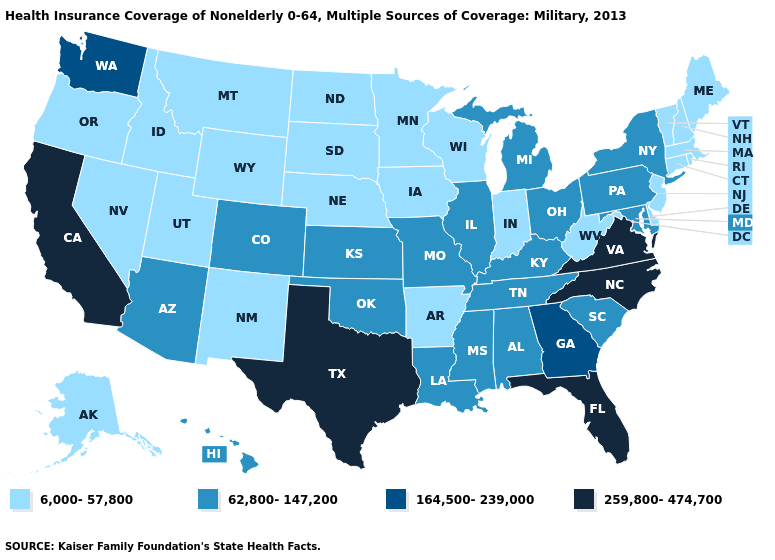Does Utah have the lowest value in the West?
Concise answer only. Yes. Name the states that have a value in the range 6,000-57,800?
Answer briefly. Alaska, Arkansas, Connecticut, Delaware, Idaho, Indiana, Iowa, Maine, Massachusetts, Minnesota, Montana, Nebraska, Nevada, New Hampshire, New Jersey, New Mexico, North Dakota, Oregon, Rhode Island, South Dakota, Utah, Vermont, West Virginia, Wisconsin, Wyoming. Which states hav the highest value in the South?
Write a very short answer. Florida, North Carolina, Texas, Virginia. Does South Carolina have a lower value than North Carolina?
Short answer required. Yes. Name the states that have a value in the range 62,800-147,200?
Concise answer only. Alabama, Arizona, Colorado, Hawaii, Illinois, Kansas, Kentucky, Louisiana, Maryland, Michigan, Mississippi, Missouri, New York, Ohio, Oklahoma, Pennsylvania, South Carolina, Tennessee. What is the value of New Mexico?
Keep it brief. 6,000-57,800. Name the states that have a value in the range 6,000-57,800?
Keep it brief. Alaska, Arkansas, Connecticut, Delaware, Idaho, Indiana, Iowa, Maine, Massachusetts, Minnesota, Montana, Nebraska, Nevada, New Hampshire, New Jersey, New Mexico, North Dakota, Oregon, Rhode Island, South Dakota, Utah, Vermont, West Virginia, Wisconsin, Wyoming. Which states have the lowest value in the MidWest?
Answer briefly. Indiana, Iowa, Minnesota, Nebraska, North Dakota, South Dakota, Wisconsin. What is the value of Nevada?
Concise answer only. 6,000-57,800. What is the value of Wisconsin?
Keep it brief. 6,000-57,800. What is the highest value in states that border Utah?
Quick response, please. 62,800-147,200. Name the states that have a value in the range 259,800-474,700?
Answer briefly. California, Florida, North Carolina, Texas, Virginia. Name the states that have a value in the range 259,800-474,700?
Keep it brief. California, Florida, North Carolina, Texas, Virginia. Does Louisiana have a higher value than Rhode Island?
Give a very brief answer. Yes. Does Massachusetts have the highest value in the USA?
Short answer required. No. 